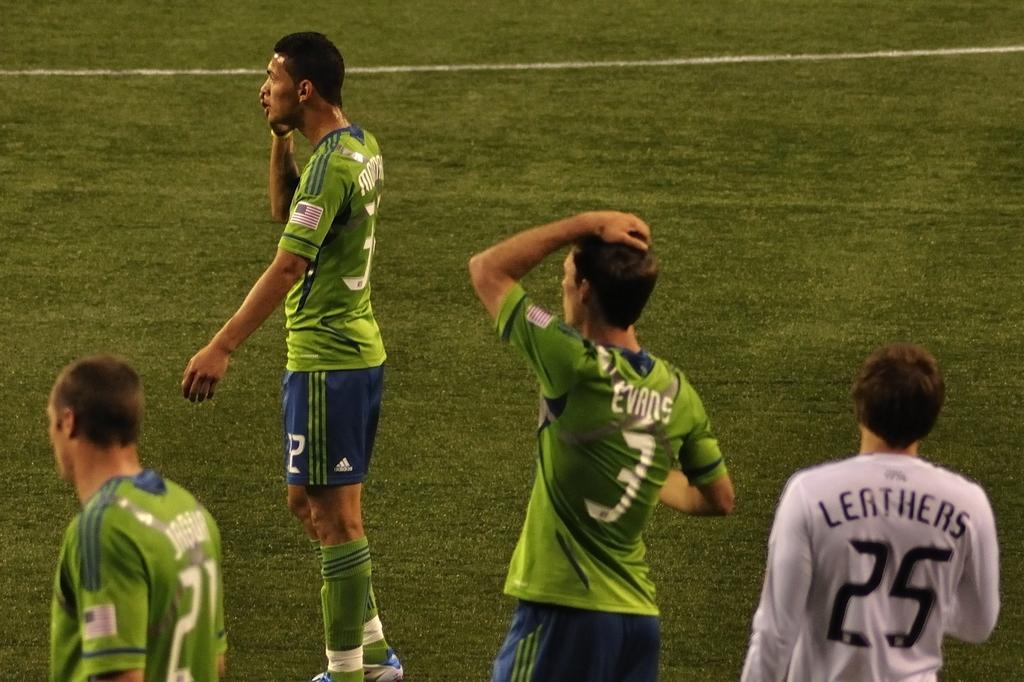What is the main subject of the image? The main subject of the image is a group of people. What colors are the people wearing in the image? The people are wearing green, blue, and white color dresses in the image. Where are the people located in the image? The people are on the ground in the image. What type of base is supporting the committee in the image? There is no committee or base present in the image; it features a group of people wearing green, blue, and white color dresses on the ground. 